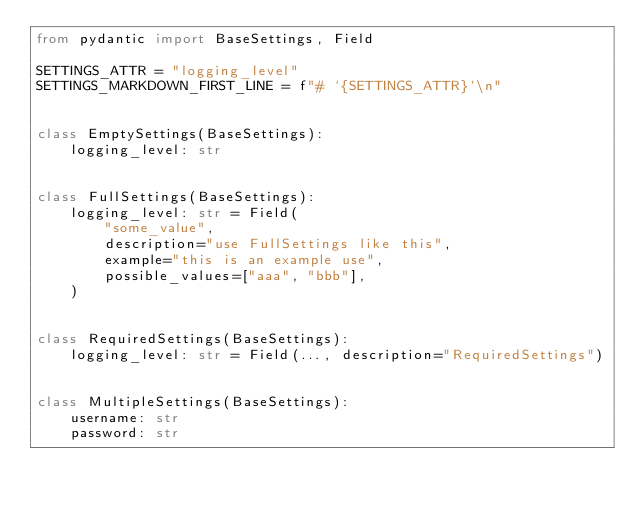<code> <loc_0><loc_0><loc_500><loc_500><_Python_>from pydantic import BaseSettings, Field

SETTINGS_ATTR = "logging_level"
SETTINGS_MARKDOWN_FIRST_LINE = f"# `{SETTINGS_ATTR}`\n"


class EmptySettings(BaseSettings):
    logging_level: str


class FullSettings(BaseSettings):
    logging_level: str = Field(
        "some_value",
        description="use FullSettings like this",
        example="this is an example use",
        possible_values=["aaa", "bbb"],
    )


class RequiredSettings(BaseSettings):
    logging_level: str = Field(..., description="RequiredSettings")


class MultipleSettings(BaseSettings):
    username: str
    password: str
</code> 